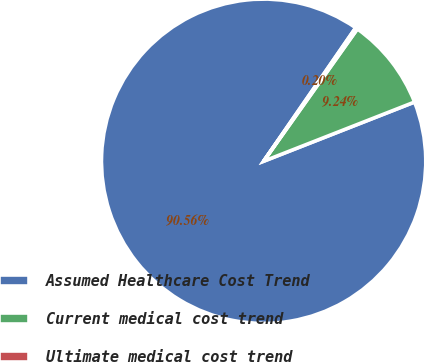Convert chart to OTSL. <chart><loc_0><loc_0><loc_500><loc_500><pie_chart><fcel>Assumed Healthcare Cost Trend<fcel>Current medical cost trend<fcel>Ultimate medical cost trend<nl><fcel>90.56%<fcel>9.24%<fcel>0.2%<nl></chart> 